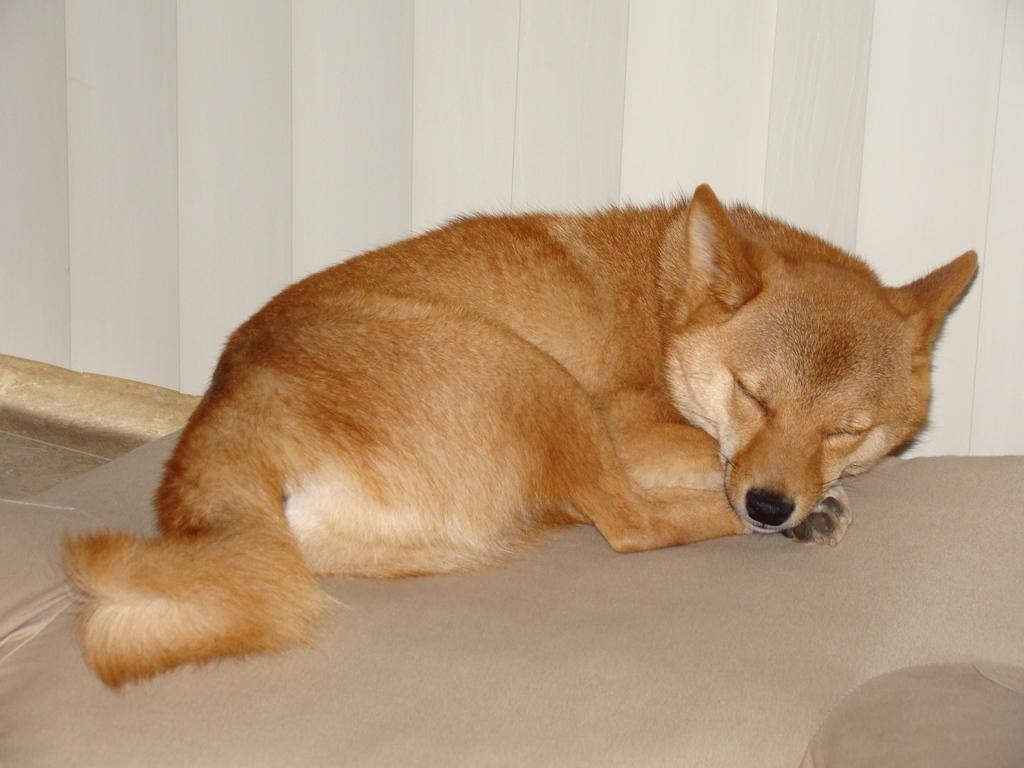What type of animal can be seen in the image? There is a dog in the image. What is the color of the dog? The dog is pale brown in color. What is the dog doing in the image? The dog is sleeping on a mat. What can be seen in the background of the image? There are window blinds visible in the image. What type of calculator is the dog using in the image? There is no calculator present in the image; the dog is sleeping on a mat. What position is the dog in while using the waste in the image? There is no waste present in the image, and the dog is sleeping on a mat. 